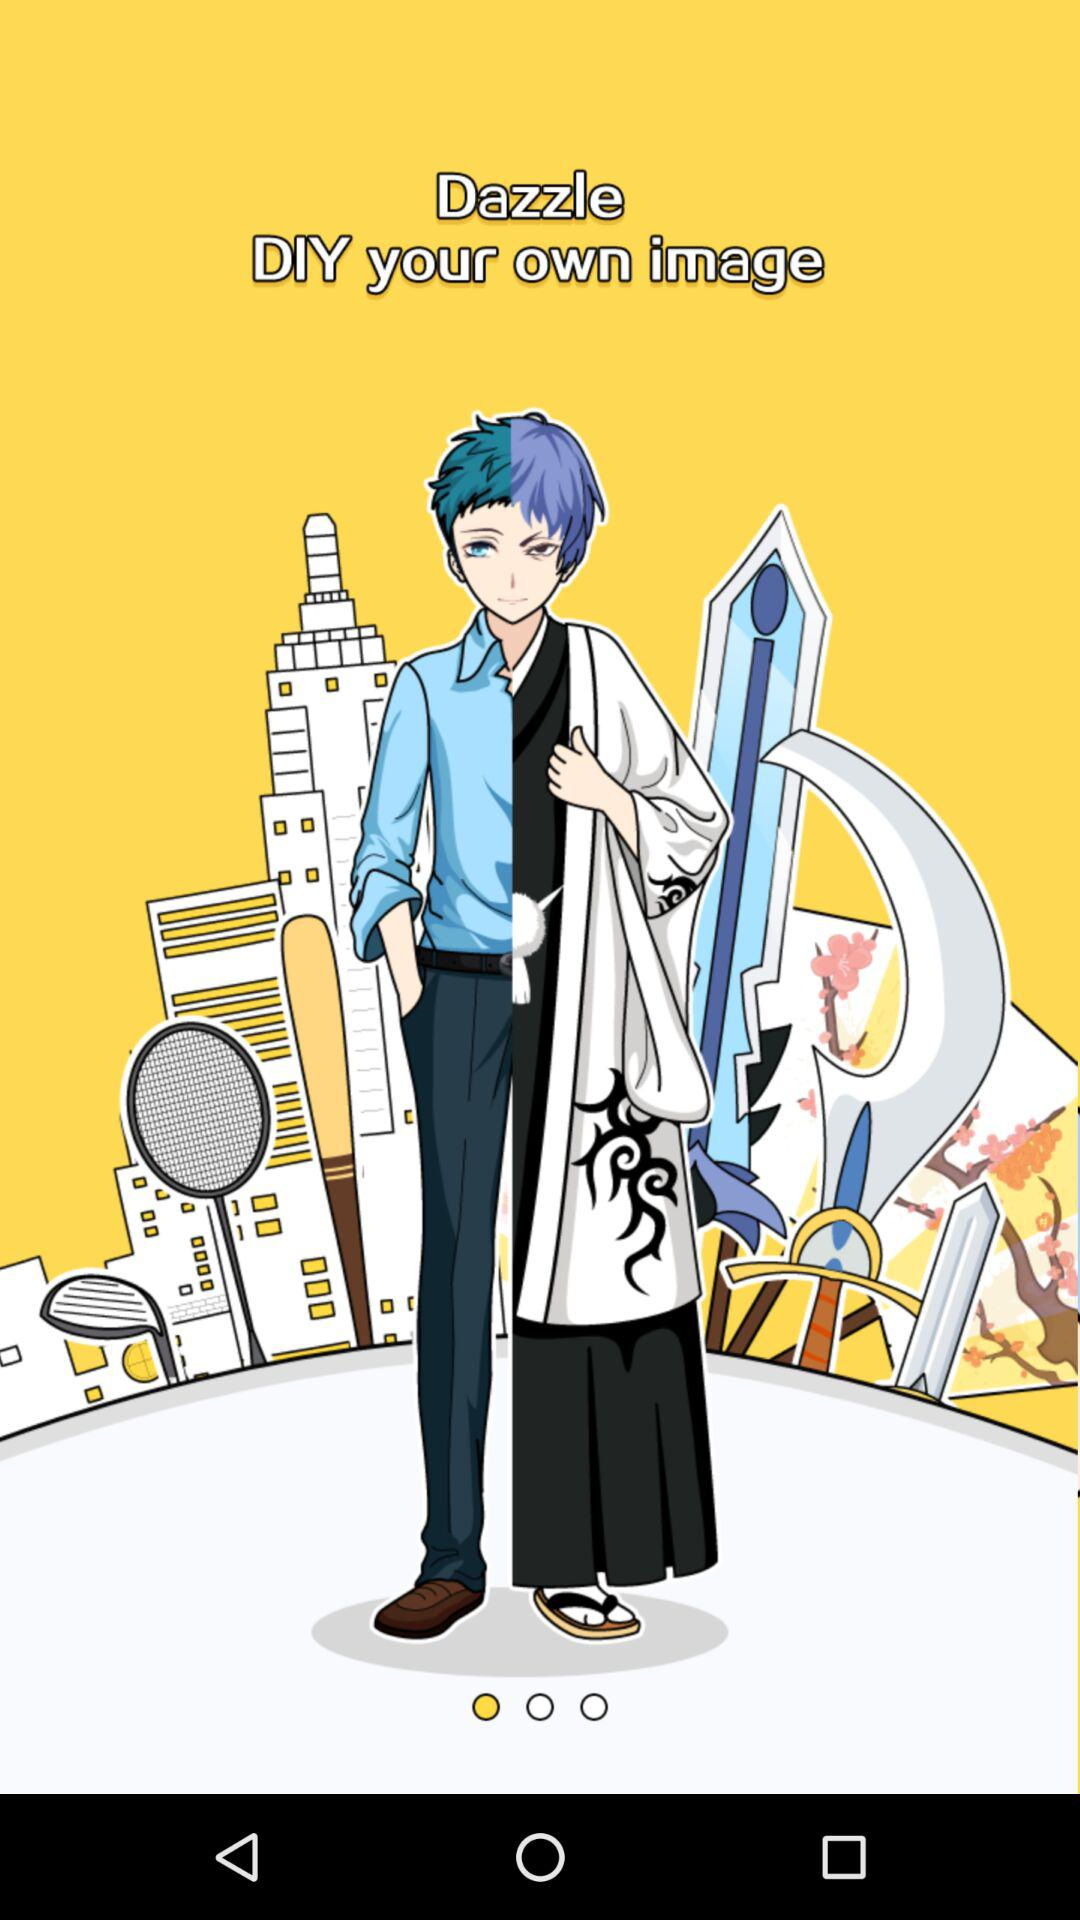Who is the artist?
When the provided information is insufficient, respond with <no answer>. <no answer> 